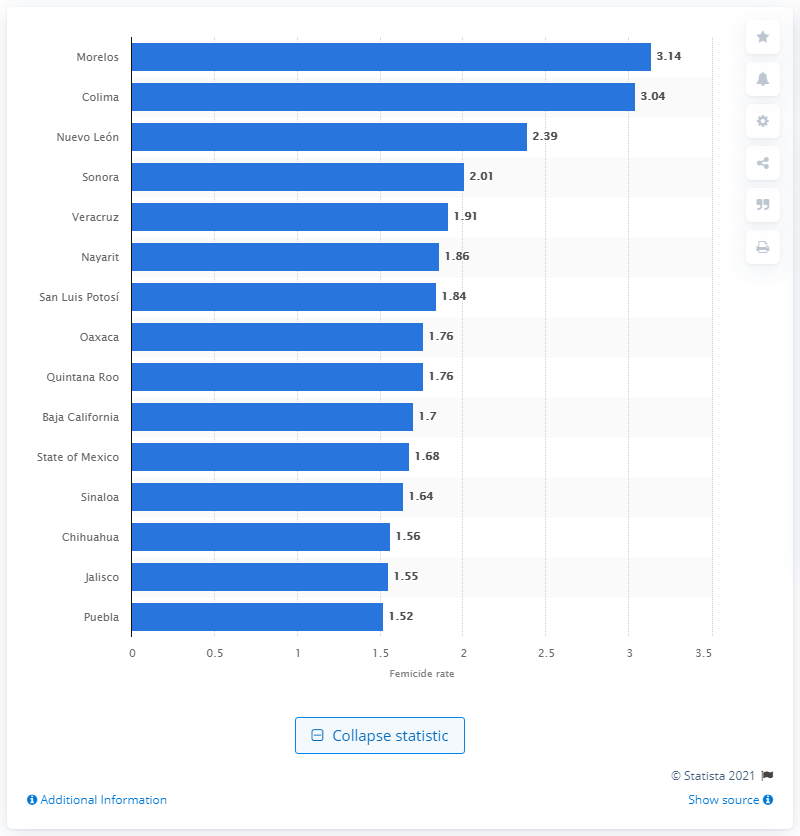Indicate a few pertinent items in this graphic. The femicide rate in the state of Morelos was 1.68 per 100,000 female inhabitants in 2020. 